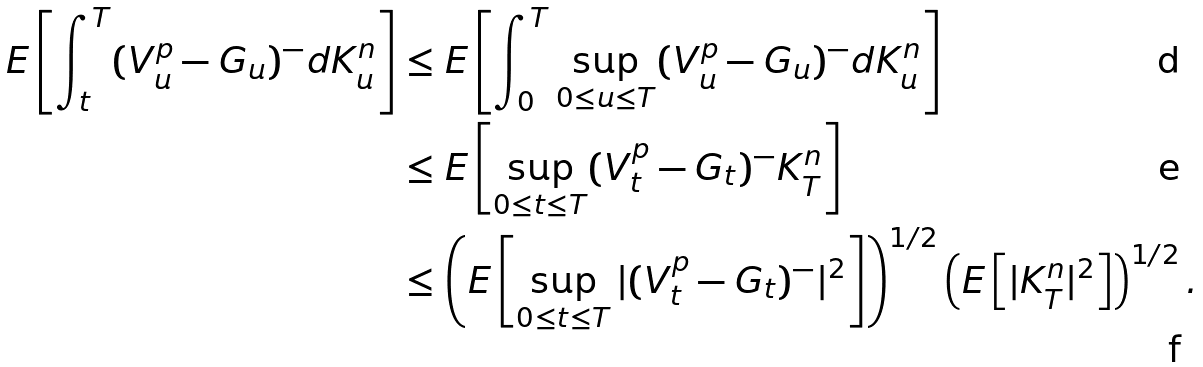<formula> <loc_0><loc_0><loc_500><loc_500>E \left [ \int _ { t } ^ { T } ( V _ { u } ^ { p } - G _ { u } ) ^ { - } d K _ { u } ^ { n } \right ] & \leq E \left [ \int _ { 0 } ^ { T } \sup _ { 0 \leq u \leq T } ( V _ { u } ^ { p } - G _ { u } ) ^ { - } d K _ { u } ^ { n } \right ] \\ & \leq E \left [ \sup _ { 0 \leq t \leq T } ( V _ { t } ^ { p } - G _ { t } ) ^ { - } K ^ { n } _ { T } \right ] \\ & \leq \left ( E \left [ \sup _ { 0 \leq t \leq T } | ( V _ { t } ^ { p } - G _ { t } ) ^ { - } | ^ { 2 } \right ] \right ) ^ { 1 / 2 } \left ( E \left [ | K _ { T } ^ { n } | ^ { 2 } \right ] \right ) ^ { 1 / 2 } .</formula> 